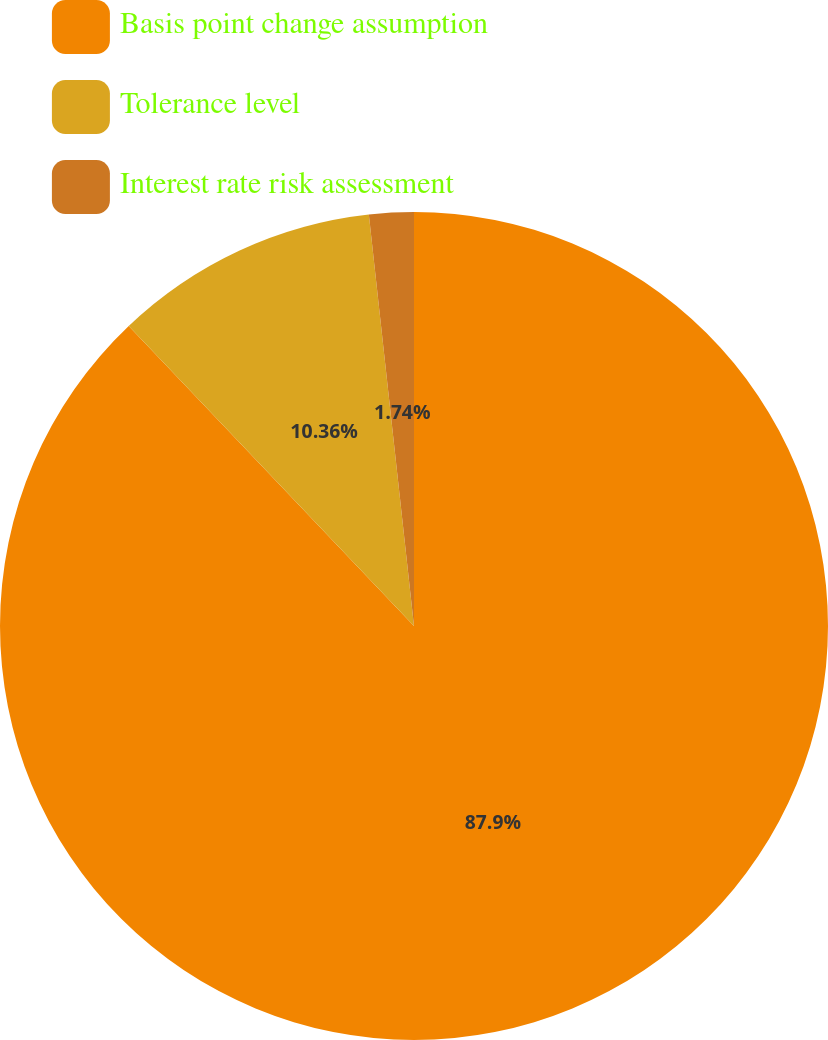Convert chart. <chart><loc_0><loc_0><loc_500><loc_500><pie_chart><fcel>Basis point change assumption<fcel>Tolerance level<fcel>Interest rate risk assessment<nl><fcel>87.91%<fcel>10.36%<fcel>1.74%<nl></chart> 